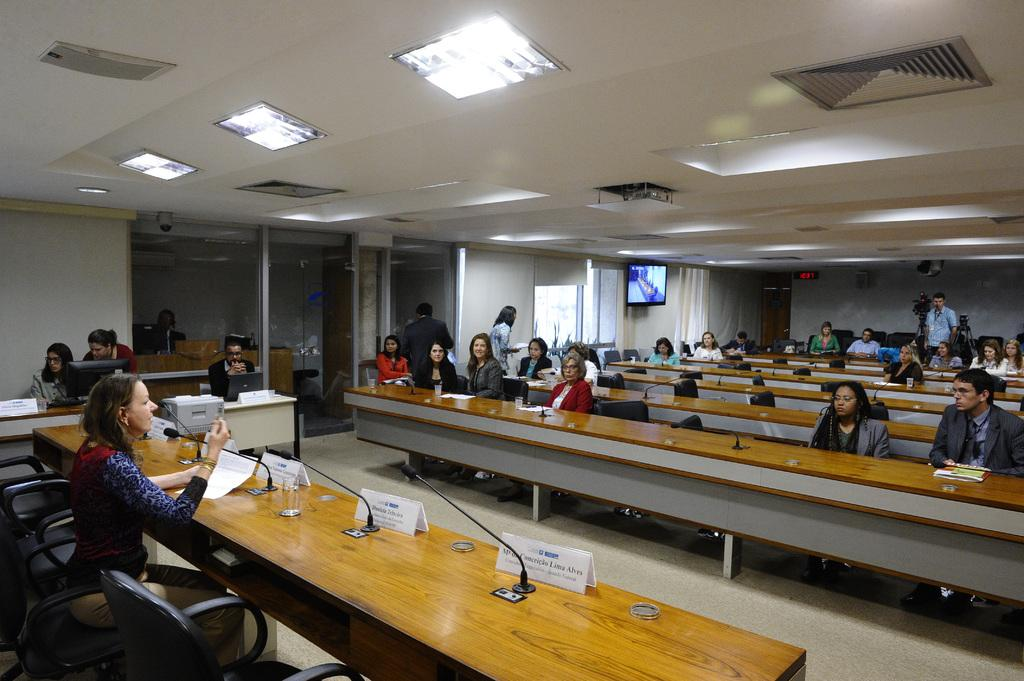What are the people in the image doing? The people in the image are sitting on chairs. Where are the chairs located in relation to the table? The chairs are near a table. What can be seen in the background of the image? There are glass windows, a monitor, and an exit board visible in the background. What type of lighting is present in the image? Lights on the ceiling are present in the image. What songs are being sung by the people sitting on chairs in the image? There is no indication in the image that the people are singing songs, so it cannot be determined from the picture. 